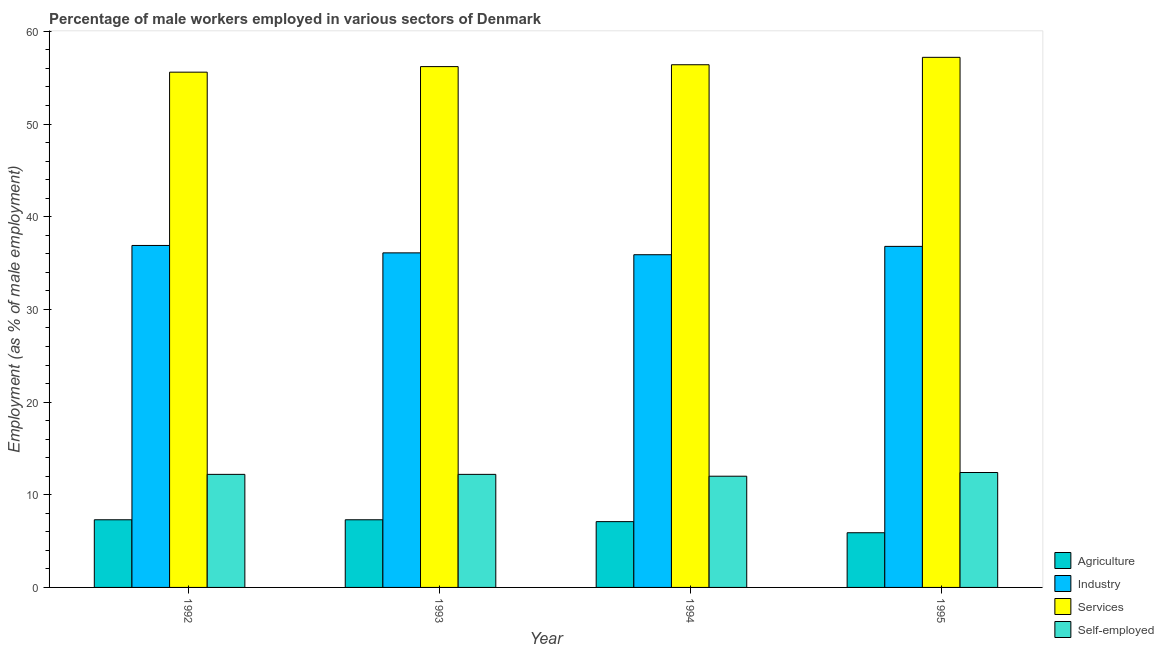How many different coloured bars are there?
Your answer should be compact. 4. How many bars are there on the 3rd tick from the right?
Offer a terse response. 4. What is the percentage of male workers in services in 1992?
Offer a very short reply. 55.6. Across all years, what is the maximum percentage of male workers in services?
Keep it short and to the point. 57.2. Across all years, what is the minimum percentage of male workers in services?
Ensure brevity in your answer.  55.6. In which year was the percentage of male workers in industry maximum?
Provide a short and direct response. 1992. In which year was the percentage of male workers in services minimum?
Give a very brief answer. 1992. What is the total percentage of self employed male workers in the graph?
Your answer should be very brief. 48.8. What is the difference between the percentage of male workers in industry in 1992 and that in 1994?
Your answer should be very brief. 1. What is the difference between the percentage of male workers in services in 1992 and the percentage of male workers in agriculture in 1993?
Provide a succinct answer. -0.6. What is the average percentage of male workers in services per year?
Your response must be concise. 56.35. What is the ratio of the percentage of male workers in services in 1994 to that in 1995?
Provide a succinct answer. 0.99. Is the percentage of male workers in industry in 1993 less than that in 1995?
Give a very brief answer. Yes. What is the difference between the highest and the second highest percentage of male workers in agriculture?
Keep it short and to the point. 0. What is the difference between the highest and the lowest percentage of male workers in agriculture?
Your response must be concise. 1.4. In how many years, is the percentage of male workers in agriculture greater than the average percentage of male workers in agriculture taken over all years?
Your response must be concise. 3. Is it the case that in every year, the sum of the percentage of self employed male workers and percentage of male workers in industry is greater than the sum of percentage of male workers in agriculture and percentage of male workers in services?
Your answer should be very brief. No. What does the 1st bar from the left in 1995 represents?
Provide a short and direct response. Agriculture. What does the 3rd bar from the right in 1992 represents?
Ensure brevity in your answer.  Industry. Is it the case that in every year, the sum of the percentage of male workers in agriculture and percentage of male workers in industry is greater than the percentage of male workers in services?
Your response must be concise. No. How many bars are there?
Your answer should be very brief. 16. Are all the bars in the graph horizontal?
Your response must be concise. No. How many years are there in the graph?
Your response must be concise. 4. What is the difference between two consecutive major ticks on the Y-axis?
Your response must be concise. 10. Are the values on the major ticks of Y-axis written in scientific E-notation?
Your answer should be very brief. No. Does the graph contain grids?
Offer a terse response. No. Where does the legend appear in the graph?
Your answer should be compact. Bottom right. How many legend labels are there?
Your response must be concise. 4. What is the title of the graph?
Make the answer very short. Percentage of male workers employed in various sectors of Denmark. What is the label or title of the X-axis?
Your answer should be very brief. Year. What is the label or title of the Y-axis?
Make the answer very short. Employment (as % of male employment). What is the Employment (as % of male employment) of Agriculture in 1992?
Your response must be concise. 7.3. What is the Employment (as % of male employment) of Industry in 1992?
Ensure brevity in your answer.  36.9. What is the Employment (as % of male employment) of Services in 1992?
Your answer should be very brief. 55.6. What is the Employment (as % of male employment) of Self-employed in 1992?
Your answer should be compact. 12.2. What is the Employment (as % of male employment) in Agriculture in 1993?
Offer a terse response. 7.3. What is the Employment (as % of male employment) in Industry in 1993?
Give a very brief answer. 36.1. What is the Employment (as % of male employment) in Services in 1993?
Your response must be concise. 56.2. What is the Employment (as % of male employment) of Self-employed in 1993?
Provide a succinct answer. 12.2. What is the Employment (as % of male employment) of Agriculture in 1994?
Your response must be concise. 7.1. What is the Employment (as % of male employment) in Industry in 1994?
Offer a terse response. 35.9. What is the Employment (as % of male employment) in Services in 1994?
Your answer should be compact. 56.4. What is the Employment (as % of male employment) in Agriculture in 1995?
Provide a short and direct response. 5.9. What is the Employment (as % of male employment) of Industry in 1995?
Make the answer very short. 36.8. What is the Employment (as % of male employment) of Services in 1995?
Offer a very short reply. 57.2. What is the Employment (as % of male employment) in Self-employed in 1995?
Your response must be concise. 12.4. Across all years, what is the maximum Employment (as % of male employment) in Agriculture?
Keep it short and to the point. 7.3. Across all years, what is the maximum Employment (as % of male employment) of Industry?
Offer a terse response. 36.9. Across all years, what is the maximum Employment (as % of male employment) in Services?
Give a very brief answer. 57.2. Across all years, what is the maximum Employment (as % of male employment) in Self-employed?
Provide a succinct answer. 12.4. Across all years, what is the minimum Employment (as % of male employment) of Agriculture?
Ensure brevity in your answer.  5.9. Across all years, what is the minimum Employment (as % of male employment) of Industry?
Provide a succinct answer. 35.9. Across all years, what is the minimum Employment (as % of male employment) of Services?
Keep it short and to the point. 55.6. Across all years, what is the minimum Employment (as % of male employment) of Self-employed?
Offer a terse response. 12. What is the total Employment (as % of male employment) in Agriculture in the graph?
Make the answer very short. 27.6. What is the total Employment (as % of male employment) in Industry in the graph?
Your answer should be very brief. 145.7. What is the total Employment (as % of male employment) in Services in the graph?
Your answer should be compact. 225.4. What is the total Employment (as % of male employment) in Self-employed in the graph?
Make the answer very short. 48.8. What is the difference between the Employment (as % of male employment) in Industry in 1992 and that in 1993?
Give a very brief answer. 0.8. What is the difference between the Employment (as % of male employment) in Self-employed in 1992 and that in 1993?
Provide a succinct answer. 0. What is the difference between the Employment (as % of male employment) in Agriculture in 1992 and that in 1994?
Your response must be concise. 0.2. What is the difference between the Employment (as % of male employment) in Industry in 1992 and that in 1994?
Your answer should be very brief. 1. What is the difference between the Employment (as % of male employment) of Services in 1992 and that in 1994?
Your answer should be very brief. -0.8. What is the difference between the Employment (as % of male employment) of Agriculture in 1992 and that in 1995?
Ensure brevity in your answer.  1.4. What is the difference between the Employment (as % of male employment) in Services in 1992 and that in 1995?
Offer a very short reply. -1.6. What is the difference between the Employment (as % of male employment) in Self-employed in 1992 and that in 1995?
Offer a very short reply. -0.2. What is the difference between the Employment (as % of male employment) of Services in 1993 and that in 1994?
Your response must be concise. -0.2. What is the difference between the Employment (as % of male employment) of Industry in 1993 and that in 1995?
Provide a succinct answer. -0.7. What is the difference between the Employment (as % of male employment) in Industry in 1994 and that in 1995?
Make the answer very short. -0.9. What is the difference between the Employment (as % of male employment) in Agriculture in 1992 and the Employment (as % of male employment) in Industry in 1993?
Offer a terse response. -28.8. What is the difference between the Employment (as % of male employment) in Agriculture in 1992 and the Employment (as % of male employment) in Services in 1993?
Offer a terse response. -48.9. What is the difference between the Employment (as % of male employment) of Industry in 1992 and the Employment (as % of male employment) of Services in 1993?
Offer a terse response. -19.3. What is the difference between the Employment (as % of male employment) of Industry in 1992 and the Employment (as % of male employment) of Self-employed in 1993?
Your response must be concise. 24.7. What is the difference between the Employment (as % of male employment) in Services in 1992 and the Employment (as % of male employment) in Self-employed in 1993?
Your answer should be compact. 43.4. What is the difference between the Employment (as % of male employment) of Agriculture in 1992 and the Employment (as % of male employment) of Industry in 1994?
Your answer should be compact. -28.6. What is the difference between the Employment (as % of male employment) of Agriculture in 1992 and the Employment (as % of male employment) of Services in 1994?
Your response must be concise. -49.1. What is the difference between the Employment (as % of male employment) of Industry in 1992 and the Employment (as % of male employment) of Services in 1994?
Ensure brevity in your answer.  -19.5. What is the difference between the Employment (as % of male employment) of Industry in 1992 and the Employment (as % of male employment) of Self-employed in 1994?
Provide a succinct answer. 24.9. What is the difference between the Employment (as % of male employment) of Services in 1992 and the Employment (as % of male employment) of Self-employed in 1994?
Offer a very short reply. 43.6. What is the difference between the Employment (as % of male employment) of Agriculture in 1992 and the Employment (as % of male employment) of Industry in 1995?
Provide a succinct answer. -29.5. What is the difference between the Employment (as % of male employment) in Agriculture in 1992 and the Employment (as % of male employment) in Services in 1995?
Ensure brevity in your answer.  -49.9. What is the difference between the Employment (as % of male employment) in Industry in 1992 and the Employment (as % of male employment) in Services in 1995?
Ensure brevity in your answer.  -20.3. What is the difference between the Employment (as % of male employment) in Services in 1992 and the Employment (as % of male employment) in Self-employed in 1995?
Your answer should be compact. 43.2. What is the difference between the Employment (as % of male employment) in Agriculture in 1993 and the Employment (as % of male employment) in Industry in 1994?
Keep it short and to the point. -28.6. What is the difference between the Employment (as % of male employment) of Agriculture in 1993 and the Employment (as % of male employment) of Services in 1994?
Provide a short and direct response. -49.1. What is the difference between the Employment (as % of male employment) in Industry in 1993 and the Employment (as % of male employment) in Services in 1994?
Give a very brief answer. -20.3. What is the difference between the Employment (as % of male employment) in Industry in 1993 and the Employment (as % of male employment) in Self-employed in 1994?
Provide a succinct answer. 24.1. What is the difference between the Employment (as % of male employment) in Services in 1993 and the Employment (as % of male employment) in Self-employed in 1994?
Offer a terse response. 44.2. What is the difference between the Employment (as % of male employment) in Agriculture in 1993 and the Employment (as % of male employment) in Industry in 1995?
Your answer should be compact. -29.5. What is the difference between the Employment (as % of male employment) of Agriculture in 1993 and the Employment (as % of male employment) of Services in 1995?
Give a very brief answer. -49.9. What is the difference between the Employment (as % of male employment) in Industry in 1993 and the Employment (as % of male employment) in Services in 1995?
Ensure brevity in your answer.  -21.1. What is the difference between the Employment (as % of male employment) of Industry in 1993 and the Employment (as % of male employment) of Self-employed in 1995?
Make the answer very short. 23.7. What is the difference between the Employment (as % of male employment) in Services in 1993 and the Employment (as % of male employment) in Self-employed in 1995?
Your answer should be very brief. 43.8. What is the difference between the Employment (as % of male employment) in Agriculture in 1994 and the Employment (as % of male employment) in Industry in 1995?
Your answer should be very brief. -29.7. What is the difference between the Employment (as % of male employment) in Agriculture in 1994 and the Employment (as % of male employment) in Services in 1995?
Provide a short and direct response. -50.1. What is the difference between the Employment (as % of male employment) in Industry in 1994 and the Employment (as % of male employment) in Services in 1995?
Your answer should be very brief. -21.3. What is the difference between the Employment (as % of male employment) of Services in 1994 and the Employment (as % of male employment) of Self-employed in 1995?
Give a very brief answer. 44. What is the average Employment (as % of male employment) of Industry per year?
Your response must be concise. 36.42. What is the average Employment (as % of male employment) of Services per year?
Provide a short and direct response. 56.35. In the year 1992, what is the difference between the Employment (as % of male employment) of Agriculture and Employment (as % of male employment) of Industry?
Your answer should be compact. -29.6. In the year 1992, what is the difference between the Employment (as % of male employment) of Agriculture and Employment (as % of male employment) of Services?
Your answer should be compact. -48.3. In the year 1992, what is the difference between the Employment (as % of male employment) in Industry and Employment (as % of male employment) in Services?
Offer a very short reply. -18.7. In the year 1992, what is the difference between the Employment (as % of male employment) of Industry and Employment (as % of male employment) of Self-employed?
Provide a succinct answer. 24.7. In the year 1992, what is the difference between the Employment (as % of male employment) in Services and Employment (as % of male employment) in Self-employed?
Make the answer very short. 43.4. In the year 1993, what is the difference between the Employment (as % of male employment) of Agriculture and Employment (as % of male employment) of Industry?
Offer a very short reply. -28.8. In the year 1993, what is the difference between the Employment (as % of male employment) in Agriculture and Employment (as % of male employment) in Services?
Give a very brief answer. -48.9. In the year 1993, what is the difference between the Employment (as % of male employment) of Agriculture and Employment (as % of male employment) of Self-employed?
Your answer should be compact. -4.9. In the year 1993, what is the difference between the Employment (as % of male employment) of Industry and Employment (as % of male employment) of Services?
Offer a terse response. -20.1. In the year 1993, what is the difference between the Employment (as % of male employment) of Industry and Employment (as % of male employment) of Self-employed?
Ensure brevity in your answer.  23.9. In the year 1994, what is the difference between the Employment (as % of male employment) of Agriculture and Employment (as % of male employment) of Industry?
Your answer should be compact. -28.8. In the year 1994, what is the difference between the Employment (as % of male employment) of Agriculture and Employment (as % of male employment) of Services?
Ensure brevity in your answer.  -49.3. In the year 1994, what is the difference between the Employment (as % of male employment) of Industry and Employment (as % of male employment) of Services?
Keep it short and to the point. -20.5. In the year 1994, what is the difference between the Employment (as % of male employment) of Industry and Employment (as % of male employment) of Self-employed?
Keep it short and to the point. 23.9. In the year 1994, what is the difference between the Employment (as % of male employment) of Services and Employment (as % of male employment) of Self-employed?
Offer a very short reply. 44.4. In the year 1995, what is the difference between the Employment (as % of male employment) of Agriculture and Employment (as % of male employment) of Industry?
Your answer should be compact. -30.9. In the year 1995, what is the difference between the Employment (as % of male employment) of Agriculture and Employment (as % of male employment) of Services?
Keep it short and to the point. -51.3. In the year 1995, what is the difference between the Employment (as % of male employment) of Industry and Employment (as % of male employment) of Services?
Your response must be concise. -20.4. In the year 1995, what is the difference between the Employment (as % of male employment) of Industry and Employment (as % of male employment) of Self-employed?
Make the answer very short. 24.4. In the year 1995, what is the difference between the Employment (as % of male employment) in Services and Employment (as % of male employment) in Self-employed?
Your answer should be very brief. 44.8. What is the ratio of the Employment (as % of male employment) in Industry in 1992 to that in 1993?
Keep it short and to the point. 1.02. What is the ratio of the Employment (as % of male employment) of Services in 1992 to that in 1993?
Ensure brevity in your answer.  0.99. What is the ratio of the Employment (as % of male employment) in Agriculture in 1992 to that in 1994?
Your answer should be very brief. 1.03. What is the ratio of the Employment (as % of male employment) in Industry in 1992 to that in 1994?
Provide a succinct answer. 1.03. What is the ratio of the Employment (as % of male employment) of Services in 1992 to that in 1994?
Give a very brief answer. 0.99. What is the ratio of the Employment (as % of male employment) of Self-employed in 1992 to that in 1994?
Your answer should be very brief. 1.02. What is the ratio of the Employment (as % of male employment) in Agriculture in 1992 to that in 1995?
Ensure brevity in your answer.  1.24. What is the ratio of the Employment (as % of male employment) of Services in 1992 to that in 1995?
Keep it short and to the point. 0.97. What is the ratio of the Employment (as % of male employment) in Self-employed in 1992 to that in 1995?
Provide a succinct answer. 0.98. What is the ratio of the Employment (as % of male employment) in Agriculture in 1993 to that in 1994?
Offer a very short reply. 1.03. What is the ratio of the Employment (as % of male employment) of Industry in 1993 to that in 1994?
Provide a succinct answer. 1.01. What is the ratio of the Employment (as % of male employment) of Services in 1993 to that in 1994?
Offer a terse response. 1. What is the ratio of the Employment (as % of male employment) in Self-employed in 1993 to that in 1994?
Your answer should be very brief. 1.02. What is the ratio of the Employment (as % of male employment) of Agriculture in 1993 to that in 1995?
Provide a succinct answer. 1.24. What is the ratio of the Employment (as % of male employment) of Industry in 1993 to that in 1995?
Your answer should be compact. 0.98. What is the ratio of the Employment (as % of male employment) of Services in 1993 to that in 1995?
Offer a very short reply. 0.98. What is the ratio of the Employment (as % of male employment) of Self-employed in 1993 to that in 1995?
Provide a short and direct response. 0.98. What is the ratio of the Employment (as % of male employment) of Agriculture in 1994 to that in 1995?
Your answer should be very brief. 1.2. What is the ratio of the Employment (as % of male employment) of Industry in 1994 to that in 1995?
Offer a terse response. 0.98. What is the difference between the highest and the second highest Employment (as % of male employment) of Agriculture?
Provide a short and direct response. 0. What is the difference between the highest and the second highest Employment (as % of male employment) in Services?
Make the answer very short. 0.8. What is the difference between the highest and the second highest Employment (as % of male employment) of Self-employed?
Offer a terse response. 0.2. What is the difference between the highest and the lowest Employment (as % of male employment) of Agriculture?
Your answer should be compact. 1.4. What is the difference between the highest and the lowest Employment (as % of male employment) in Self-employed?
Ensure brevity in your answer.  0.4. 